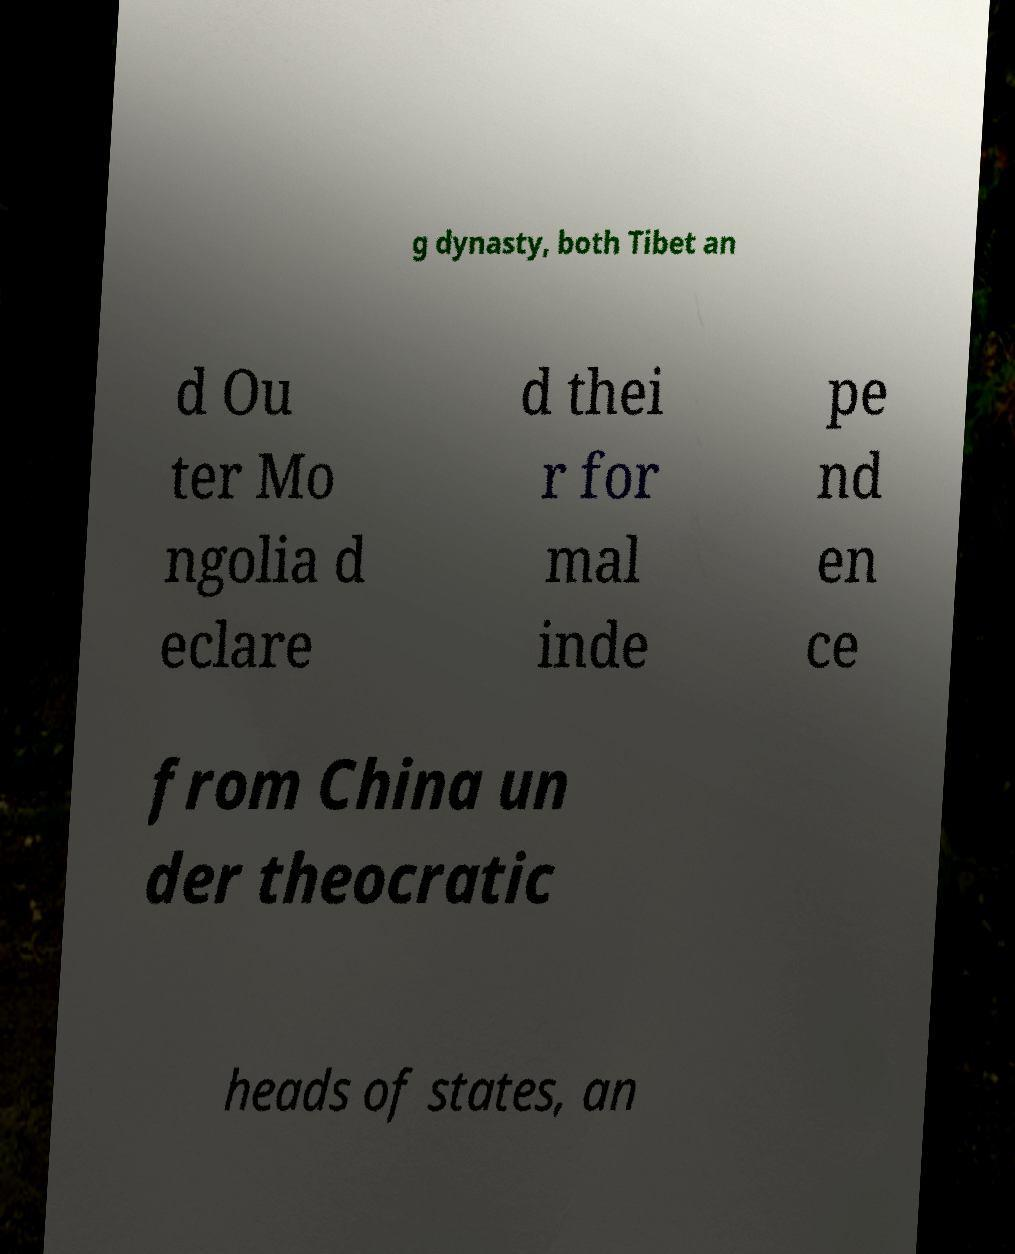I need the written content from this picture converted into text. Can you do that? g dynasty, both Tibet an d Ou ter Mo ngolia d eclare d thei r for mal inde pe nd en ce from China un der theocratic heads of states, an 